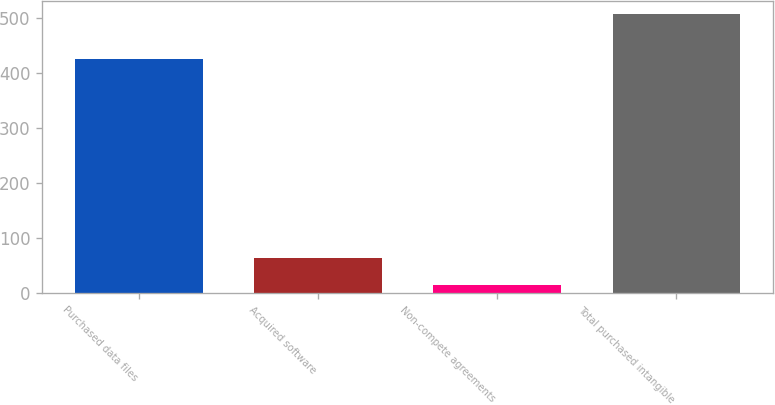<chart> <loc_0><loc_0><loc_500><loc_500><bar_chart><fcel>Purchased data files<fcel>Acquired software<fcel>Non-compete agreements<fcel>Total purchased intangible<nl><fcel>424.9<fcel>63.3<fcel>14.1<fcel>506.1<nl></chart> 